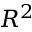Convert formula to latex. <formula><loc_0><loc_0><loc_500><loc_500>R ^ { 2 }</formula> 